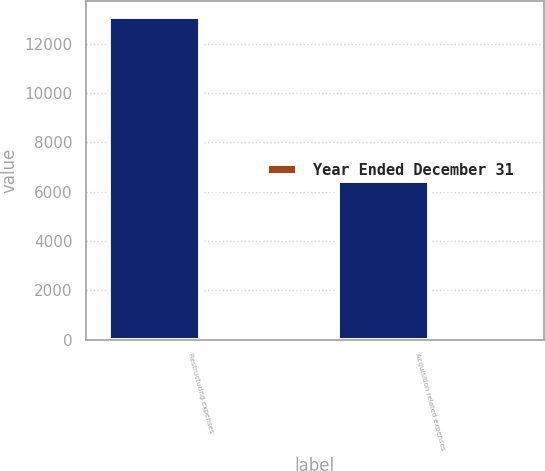Convert chart to OTSL. <chart><loc_0><loc_0><loc_500><loc_500><stacked_bar_chart><ecel><fcel>Restructuring expenses<fcel>Acquisition related expenses<nl><fcel>nan<fcel>13083<fcel>6428<nl><fcel>Year Ended December 31<fcel>2<fcel>4<nl></chart> 